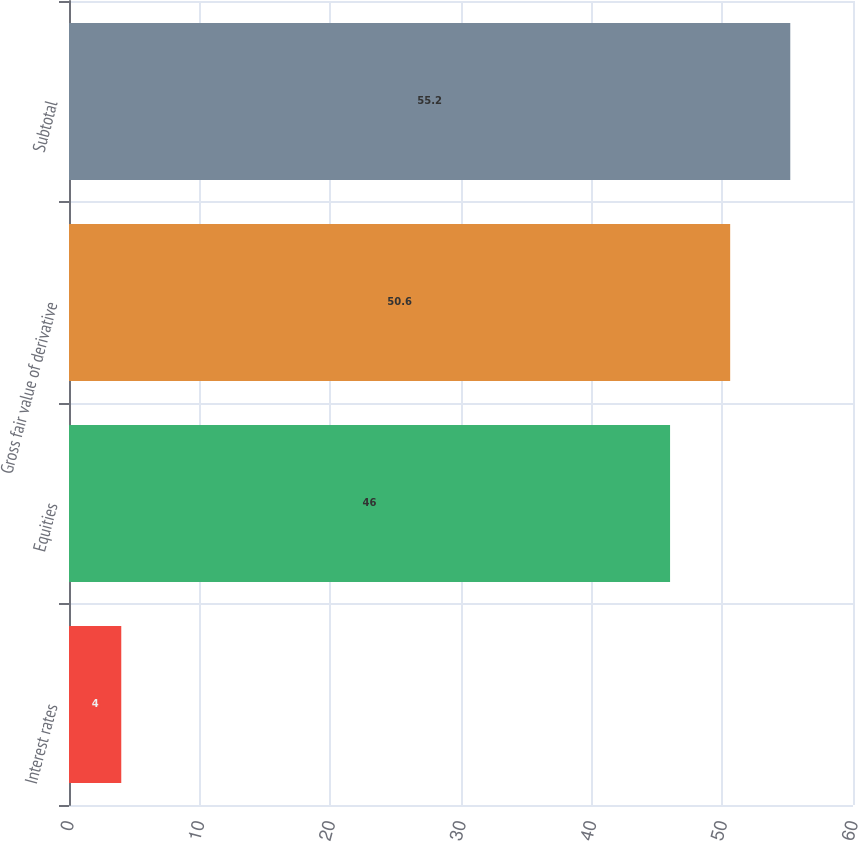<chart> <loc_0><loc_0><loc_500><loc_500><bar_chart><fcel>Interest rates<fcel>Equities<fcel>Gross fair value of derivative<fcel>Subtotal<nl><fcel>4<fcel>46<fcel>50.6<fcel>55.2<nl></chart> 